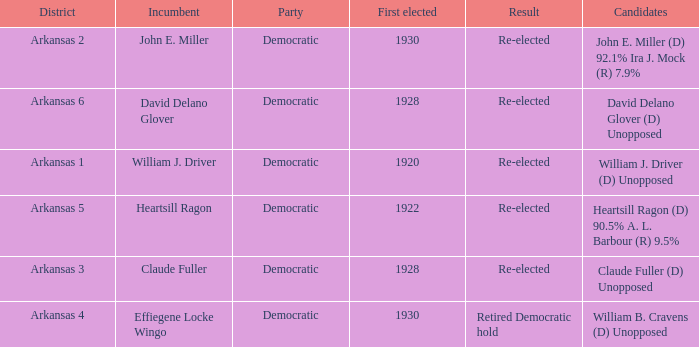Who participated in the election where claude fuller was the current officeholder? Claude Fuller (D) Unopposed. 